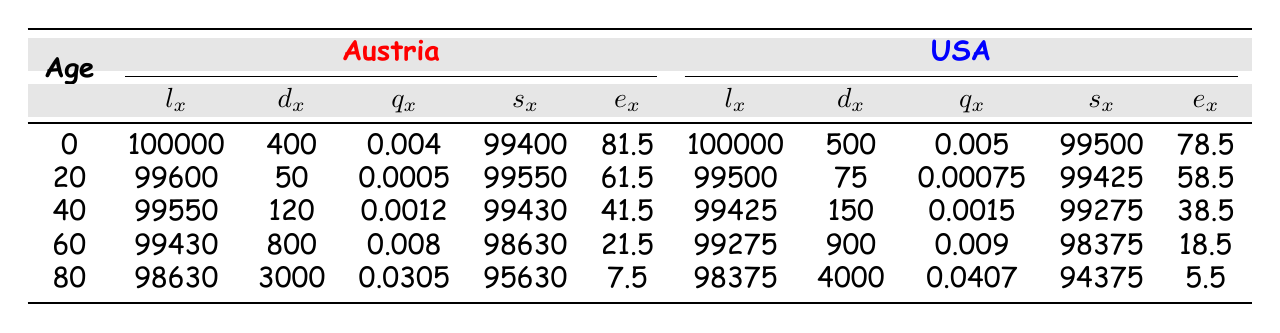What is the life expectancy at age 0 in Austria? From the table, under Austria for age 0, the life expectancy (e_x) is listed as 81.5.
Answer: 81.5 What is the probability of dying before reaching age 20 in the USA? Looking at the USA data, for age 0, the probability of dying (q_x) is 0.005. This means the probability of a newborn in the USA dying before reaching age 20 is derived from the same value as it’s a cumulative measure for the first age group.
Answer: 0.005 What is the difference in life expectancy between Austria and the USA at age 80? In Austria, the life expectancy at age 80 (e_x) is 7.5 and in the USA, it is 5.5. The difference is calculated as 7.5 - 5.5 = 2.
Answer: 2 Is the probability of dying at age 60 greater in the USA compared to Austria? For age 60, the probability of dying in Austria (q_x) is 0.008 and in the USA, it is 0.009. Since 0.009 is greater than 0.008, we confirm that the probability of dying at age 60 is indeed greater in the USA.
Answer: Yes What is the total number of people who die at age 80 in both Austria and the USA? For Austria at age 80, the number of deaths (d_x) is 3000 and for the USA, it is 4000. We sum these values: 3000 + 4000 = 7000.
Answer: 7000 What is the average probability of dying across all age groups in Austria? To find the average probability of dying (q_x) across all age groups in Austria, we first sum the probabilities: 0.004 + 0.0005 + 0.0012 + 0.008 + 0.0305 = 0.0442. There are 5 age groups, so the average is 0.0442 / 5 = 0.00884.
Answer: 0.00884 What age group has the highest number of deaths in the USA? By checking the d_x column for USA, the highest number is at age 80 with 4000 deaths.
Answer: Age 80 Which age group in Austria has the lowest probability of dying? From the q_x column in the Austrian section, the lowest value is at age 20, where q_x is 0.0005.
Answer: Age 20 What is the ratio of the number of deaths at age 60 between the USA and Austria? The number of deaths at age 60 in Austria (d_x) is 800, and in the USA, it's 900. The ratio is calculated as 900 / 800 = 1.125.
Answer: 1.125 